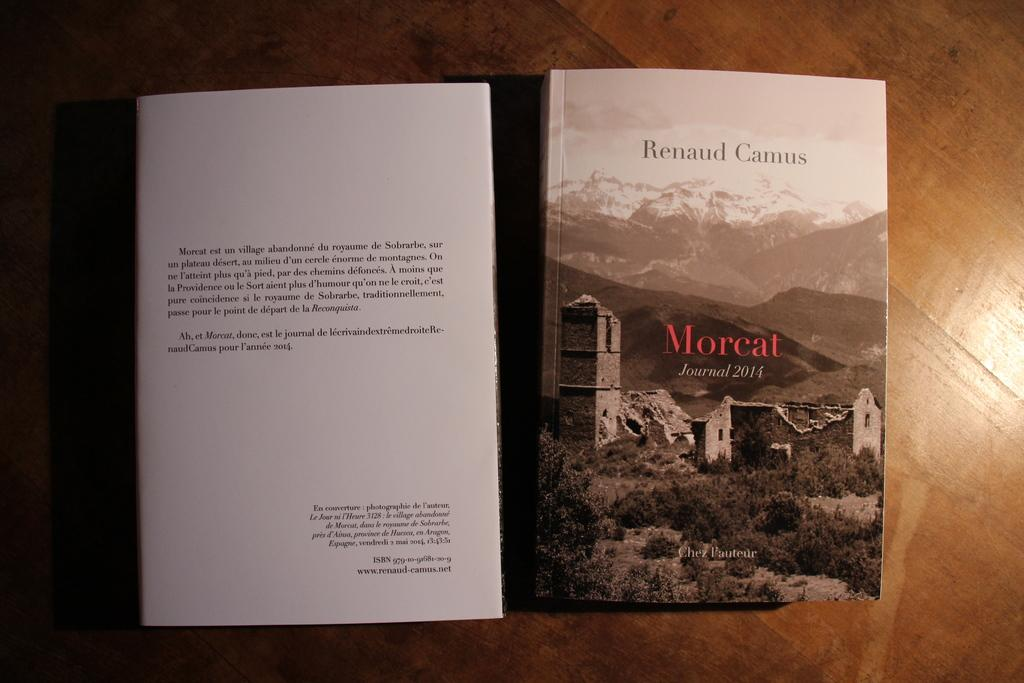<image>
Summarize the visual content of the image. An open book titled "Morcat" placed face down on a surface. 